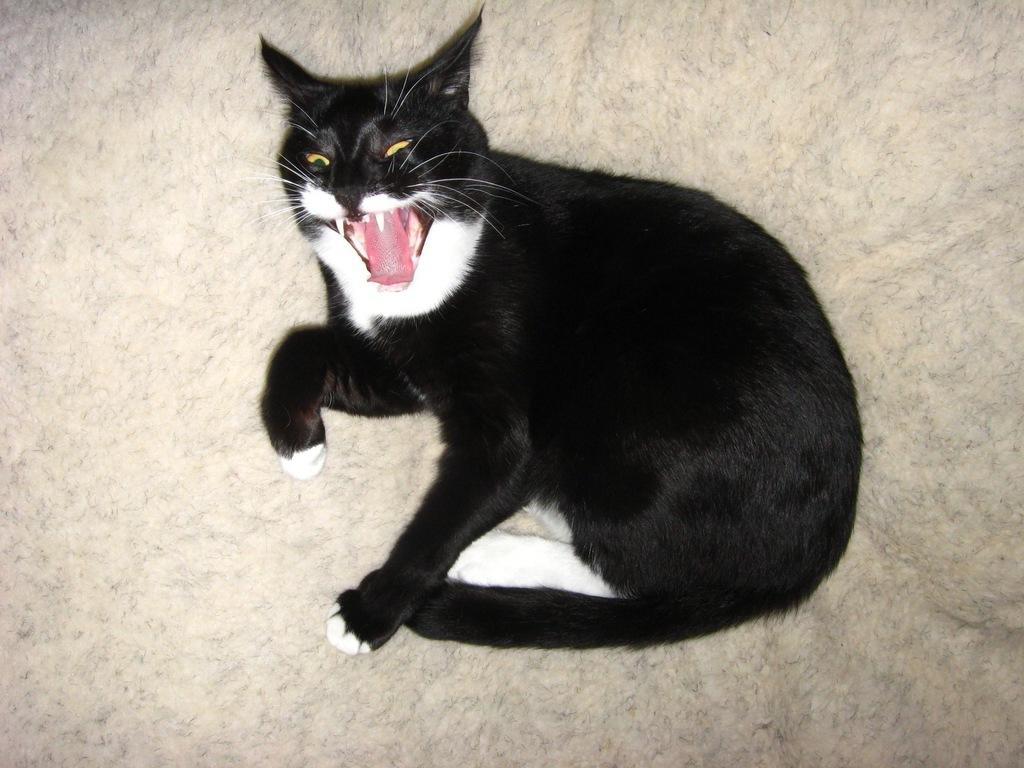Could you give a brief overview of what you see in this image? In this picture we can see a black cat on the surface. 